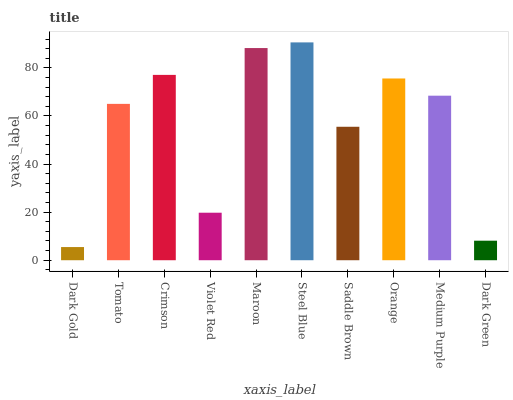Is Tomato the minimum?
Answer yes or no. No. Is Tomato the maximum?
Answer yes or no. No. Is Tomato greater than Dark Gold?
Answer yes or no. Yes. Is Dark Gold less than Tomato?
Answer yes or no. Yes. Is Dark Gold greater than Tomato?
Answer yes or no. No. Is Tomato less than Dark Gold?
Answer yes or no. No. Is Medium Purple the high median?
Answer yes or no. Yes. Is Tomato the low median?
Answer yes or no. Yes. Is Violet Red the high median?
Answer yes or no. No. Is Saddle Brown the low median?
Answer yes or no. No. 